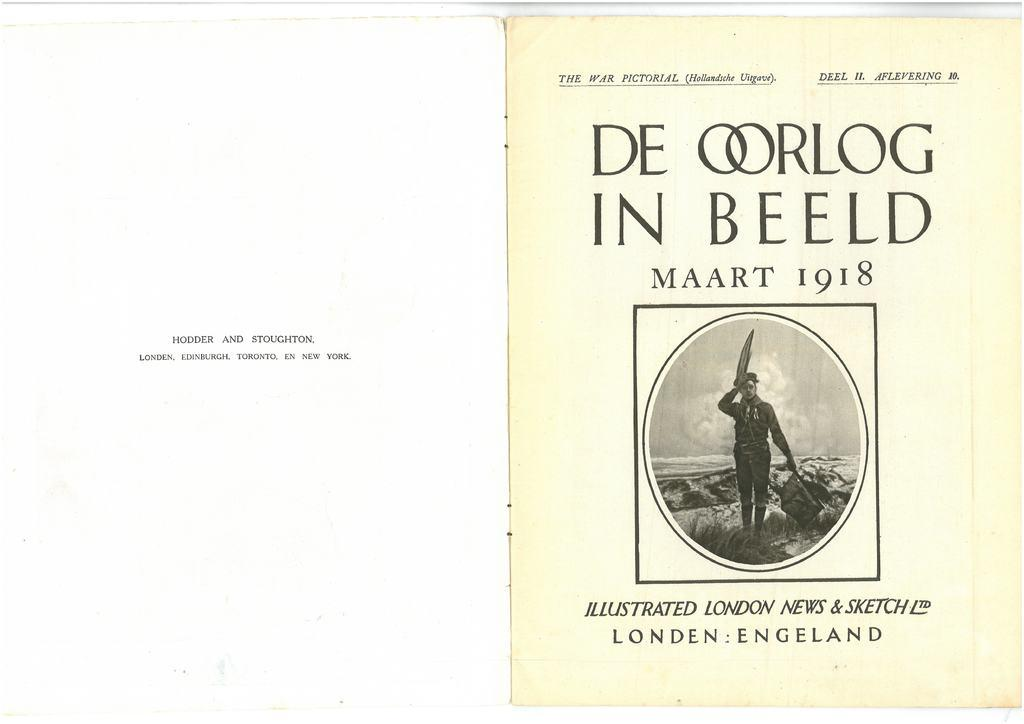<image>
Render a clear and concise summary of the photo. The first two introductory pages of an illustrated book called De Oorlog in Beeld. 